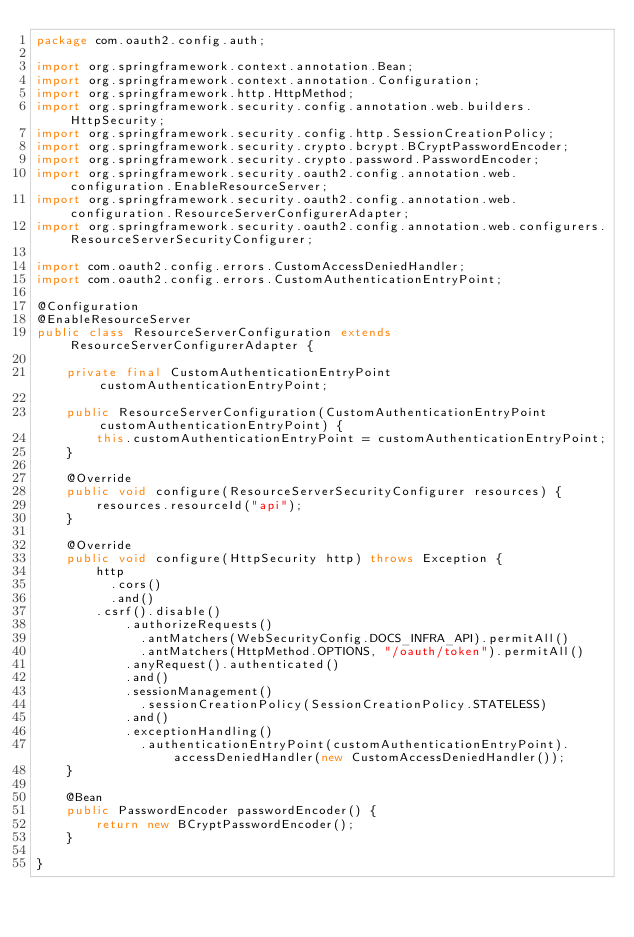Convert code to text. <code><loc_0><loc_0><loc_500><loc_500><_Java_>package com.oauth2.config.auth;

import org.springframework.context.annotation.Bean;
import org.springframework.context.annotation.Configuration;
import org.springframework.http.HttpMethod;
import org.springframework.security.config.annotation.web.builders.HttpSecurity;
import org.springframework.security.config.http.SessionCreationPolicy;
import org.springframework.security.crypto.bcrypt.BCryptPasswordEncoder;
import org.springframework.security.crypto.password.PasswordEncoder;
import org.springframework.security.oauth2.config.annotation.web.configuration.EnableResourceServer;
import org.springframework.security.oauth2.config.annotation.web.configuration.ResourceServerConfigurerAdapter;
import org.springframework.security.oauth2.config.annotation.web.configurers.ResourceServerSecurityConfigurer;

import com.oauth2.config.errors.CustomAccessDeniedHandler;
import com.oauth2.config.errors.CustomAuthenticationEntryPoint;

@Configuration
@EnableResourceServer
public class ResourceServerConfiguration extends ResourceServerConfigurerAdapter {
	
    private final CustomAuthenticationEntryPoint customAuthenticationEntryPoint;

    public ResourceServerConfiguration(CustomAuthenticationEntryPoint customAuthenticationEntryPoint) {
        this.customAuthenticationEntryPoint = customAuthenticationEntryPoint;
    }

    @Override
    public void configure(ResourceServerSecurityConfigurer resources) {
        resources.resourceId("api");
    }

    @Override
    public void configure(HttpSecurity http) throws Exception {
        http
        	.cors()
        	.and()
    		.csrf().disable()
            .authorizeRequests()
            	.antMatchers(WebSecurityConfig.DOCS_INFRA_API).permitAll()
            	.antMatchers(HttpMethod.OPTIONS, "/oauth/token").permitAll()
            .anyRequest().authenticated()
            .and()
            .sessionManagement()
            	.sessionCreationPolicy(SessionCreationPolicy.STATELESS)
            .and()
            .exceptionHandling()
            	.authenticationEntryPoint(customAuthenticationEntryPoint).accessDeniedHandler(new CustomAccessDeniedHandler());
    }
    
    @Bean
    public PasswordEncoder passwordEncoder() {
        return new BCryptPasswordEncoder();
    }
    
}</code> 